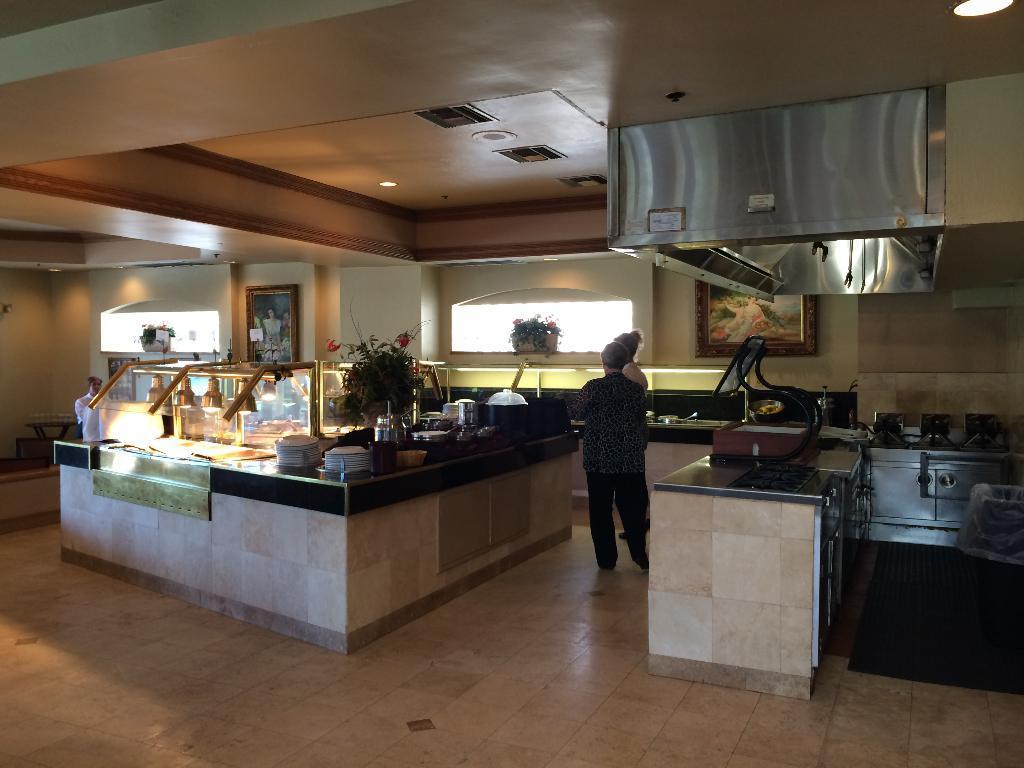Could you give a brief overview of what you see in this image? In the image we can see there are people standing and wearing clothes. We can even see plates and metal containers. We can even see plant pots. Here we can see stove, window and the floor. It's looks like the kitchens. 